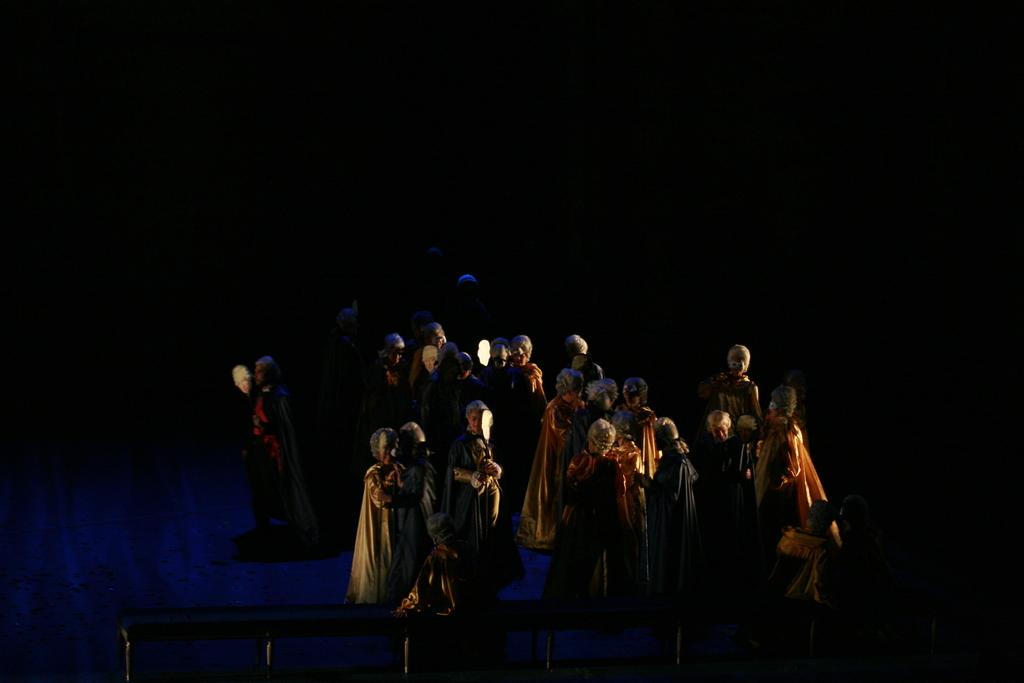What are the people in the image wearing? The people in the image are wearing costumes. What else can be seen in the image besides the people in costumes? There are rods visible in the image. What type of wound can be seen on the person's arm in the image? There is no wound visible on any person's arm in the image. What kind of pipe is being used by the people in the image? There is no pipe present in the image. 